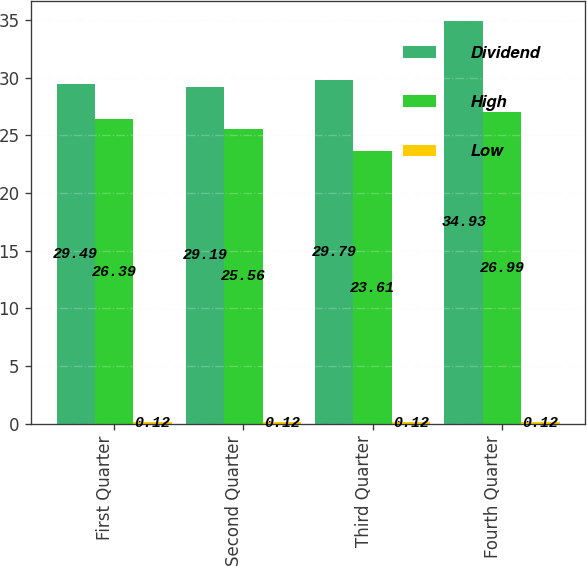Convert chart to OTSL. <chart><loc_0><loc_0><loc_500><loc_500><stacked_bar_chart><ecel><fcel>First Quarter<fcel>Second Quarter<fcel>Third Quarter<fcel>Fourth Quarter<nl><fcel>Dividend<fcel>29.49<fcel>29.19<fcel>29.79<fcel>34.93<nl><fcel>High<fcel>26.39<fcel>25.56<fcel>23.61<fcel>26.99<nl><fcel>Low<fcel>0.12<fcel>0.12<fcel>0.12<fcel>0.12<nl></chart> 